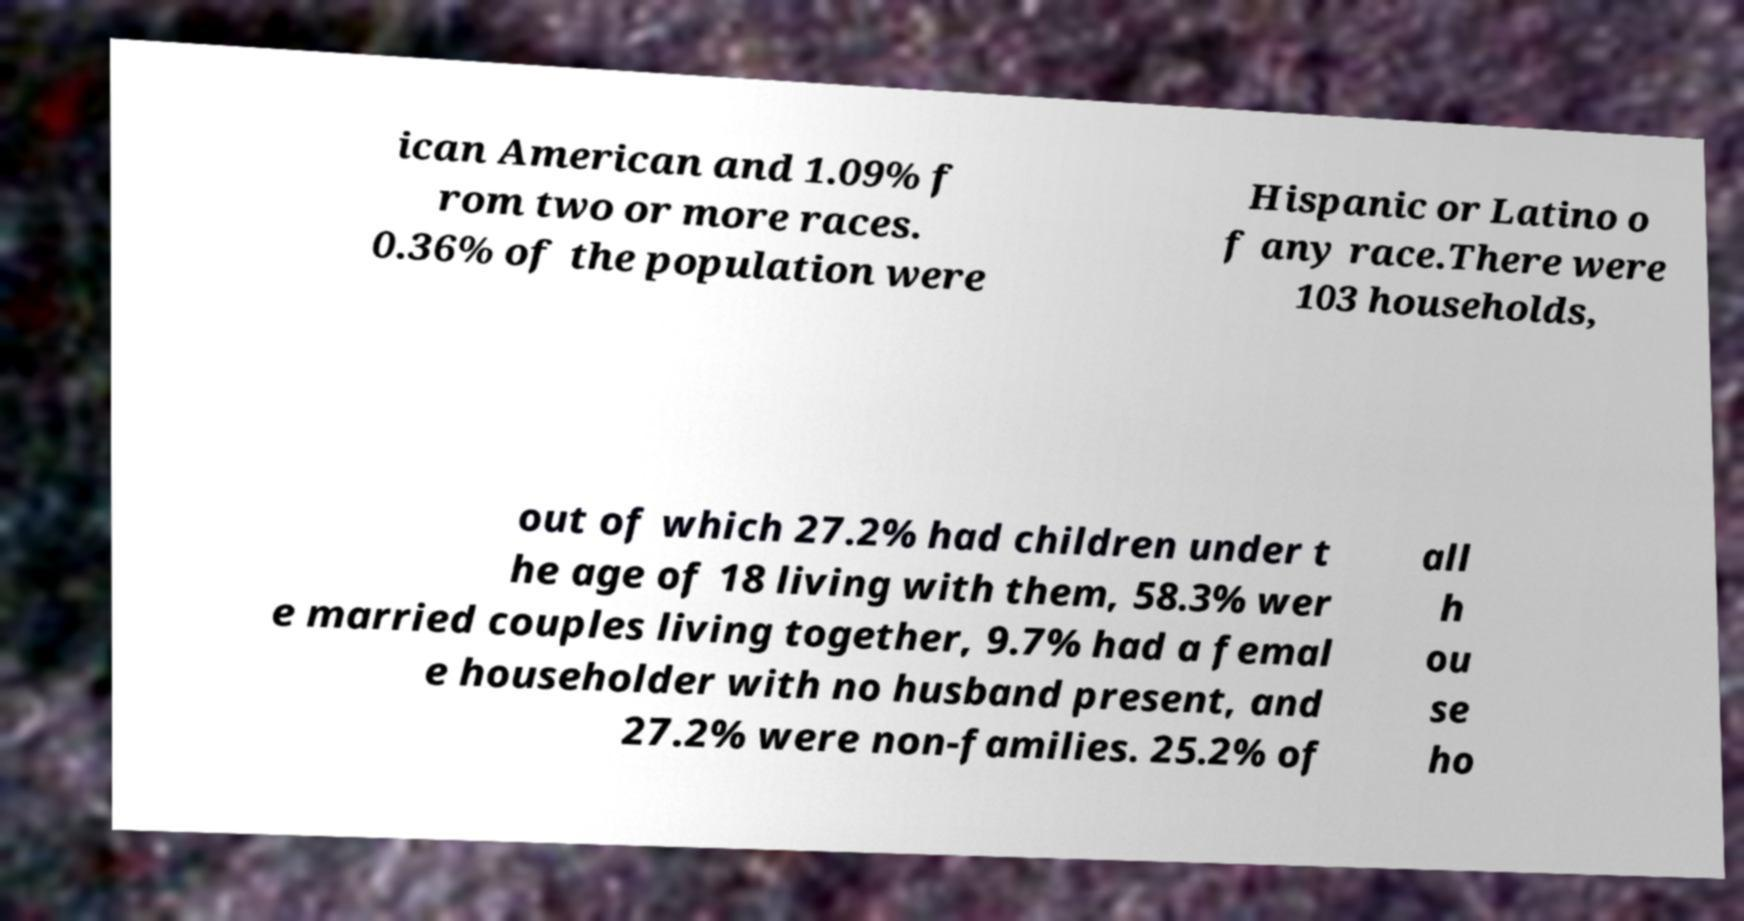What messages or text are displayed in this image? I need them in a readable, typed format. ican American and 1.09% f rom two or more races. 0.36% of the population were Hispanic or Latino o f any race.There were 103 households, out of which 27.2% had children under t he age of 18 living with them, 58.3% wer e married couples living together, 9.7% had a femal e householder with no husband present, and 27.2% were non-families. 25.2% of all h ou se ho 